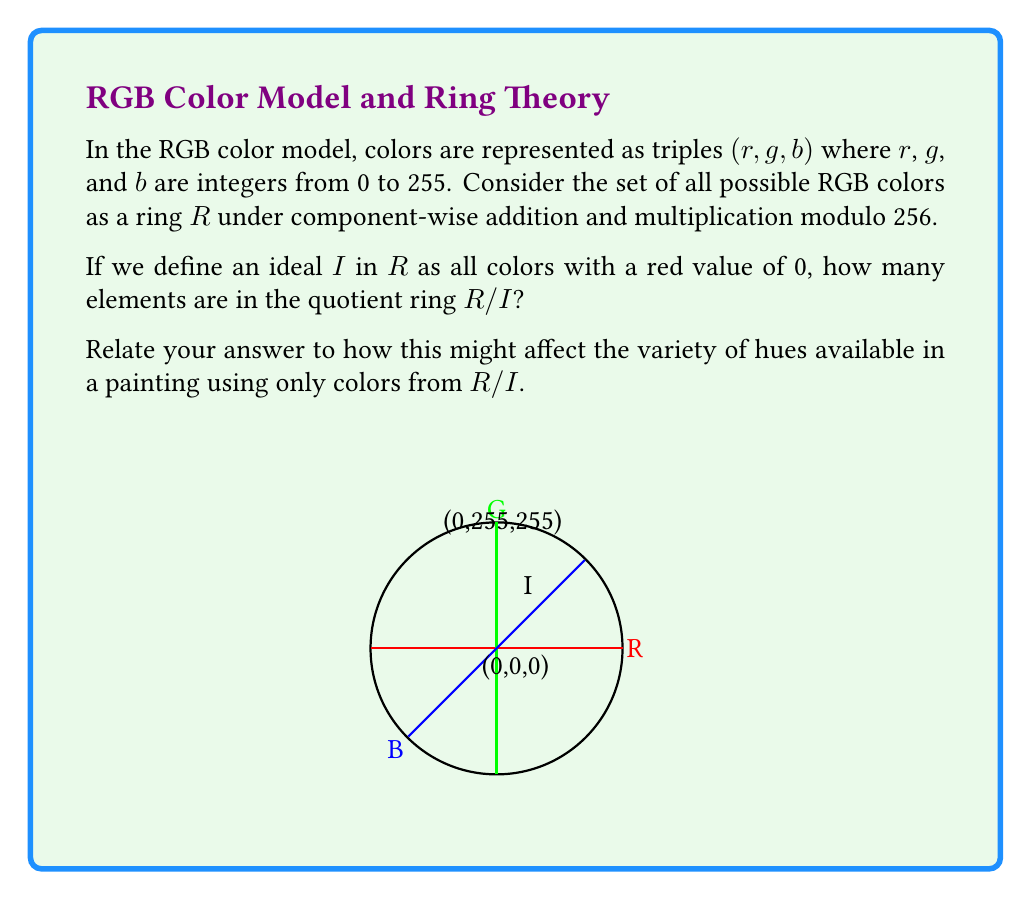Can you solve this math problem? Let's approach this step-by-step:

1) First, let's understand what the ring R represents:
   R = {(r,g,b) | r,g,b ∈ {0,1,2,...,255}}
   
   The total number of elements in R is 256³ = 16,777,216.

2) The ideal I is defined as:
   I = {(0,g,b) | g,b ∈ {0,1,2,...,255}}
   
   The number of elements in I is 256² = 65,536.

3) In ring theory, the quotient ring R/I is the set of cosets of I in R. Each coset is of the form a + I, where a ∈ R.

4) Two elements a and b of R are in the same coset of I if and only if a - b ∈ I. In our case, this means that (r₁,g₁,b₁) and (r₂,g₂,b₂) are in the same coset if and only if r₁ ≡ r₂ (mod 256).

5) Therefore, the number of distinct cosets (which is the number of elements in R/I) is equal to the number of possible values for the red component, which is 256.

6) In terms of painting, this quotient ring R/I represents all colors with the red component "factored out". Each element of R/I represents a family of colors that differ only in their red component.

7) For a painter, this means that while you still have access to all possible green and blue combinations, you lose the ability to independently control the red component. This would significantly reduce the variety of warm tones and make it challenging to create certain hues like oranges, pinks, and purples.
Answer: 256 elements; limits warm tones 